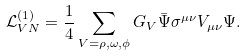Convert formula to latex. <formula><loc_0><loc_0><loc_500><loc_500>\mathcal { L } _ { V N } ^ { ( 1 ) } = \frac { 1 } { 4 } \sum _ { V = \rho , \omega , \phi } G _ { V } \bar { \Psi } \sigma ^ { \mu \nu } V _ { \mu \nu } \Psi .</formula> 